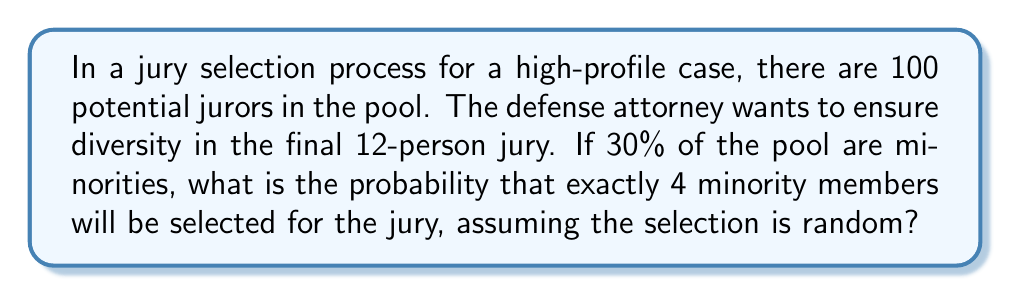Help me with this question. To solve this problem, we'll use the binomial probability formula, as this is a situation where we have a fixed number of independent trials (selecting 12 jurors) with two possible outcomes for each trial (minority or non-minority).

Step 1: Identify the components of the binomial probability formula:
$P(X = k) = \binom{n}{k} p^k (1-p)^{n-k}$
Where:
$n$ = number of trials (12 jurors to be selected)
$k$ = number of successes (4 minority members)
$p$ = probability of success on each trial (30% = 0.30)

Step 2: Calculate the binomial coefficient:
$\binom{12}{4} = \frac{12!}{4!(12-4)!} = \frac{12!}{4!8!} = 495$

Step 3: Apply the formula:
$$P(X = 4) = \binom{12}{4} (0.30)^4 (1-0.30)^{12-4}$$
$$= 495 \cdot (0.30)^4 \cdot (0.70)^8$$

Step 4: Calculate the result:
$$= 495 \cdot 0.0081 \cdot 0.0576 = 0.2304$$

Therefore, the probability of selecting exactly 4 minority members for the 12-person jury is approximately 0.2304 or 23.04%.
Answer: 0.2304 